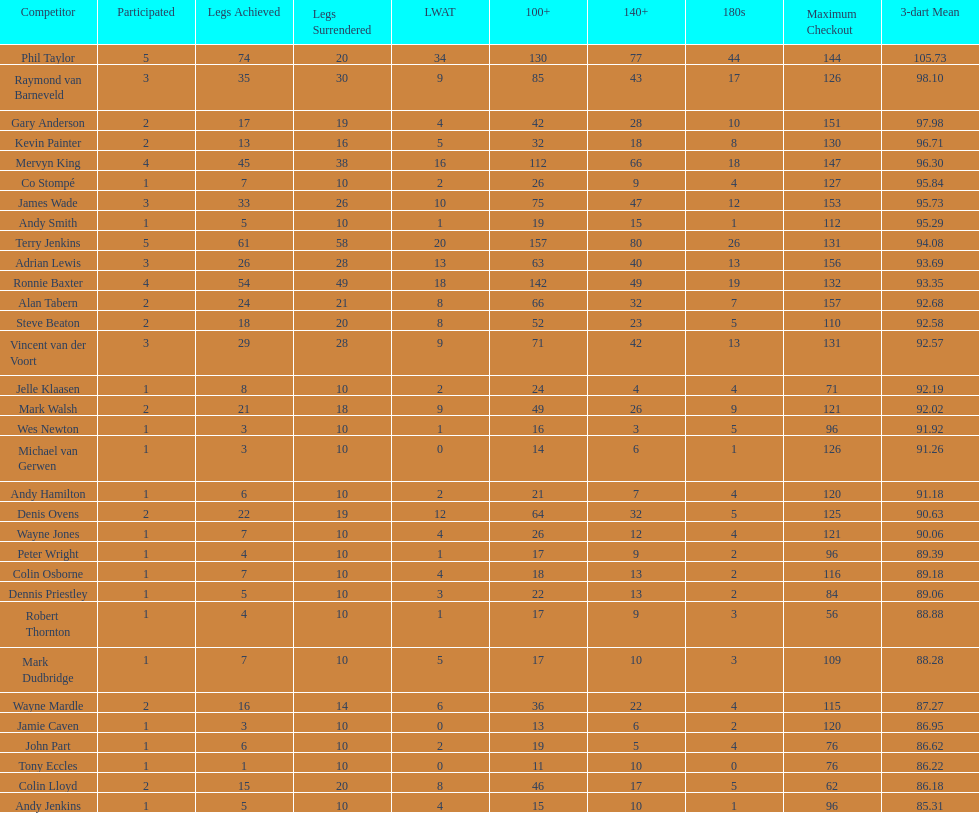What is the name of the player coming after mark walsh? Wes Newton. 